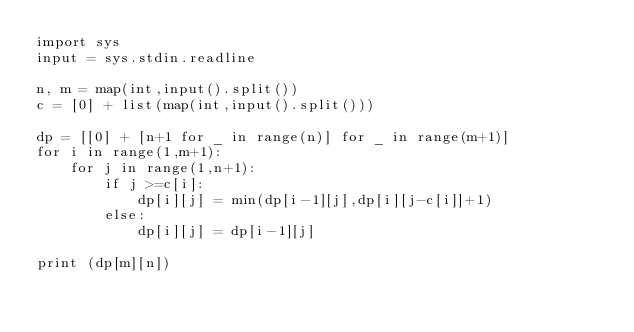<code> <loc_0><loc_0><loc_500><loc_500><_Python_>import sys
input = sys.stdin.readline

n, m = map(int,input().split())
c = [0] + list(map(int,input().split()))

dp = [[0] + [n+1 for _ in range(n)] for _ in range(m+1)]
for i in range(1,m+1):
    for j in range(1,n+1):
        if j >=c[i]:
            dp[i][j] = min(dp[i-1][j],dp[i][j-c[i]]+1)
        else:
            dp[i][j] = dp[i-1][j]

print (dp[m][n])
</code> 